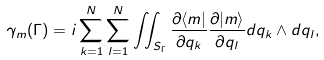<formula> <loc_0><loc_0><loc_500><loc_500>\gamma _ { m } ( \Gamma ) = i \sum _ { k = 1 } ^ { N } \sum _ { l = 1 } ^ { N } \iint _ { S _ { \Gamma } } \frac { \partial \langle m | } { \partial q _ { k } } \frac { \partial | m \rangle } { \partial q _ { l } } d q _ { k } \wedge d q _ { l } ,</formula> 